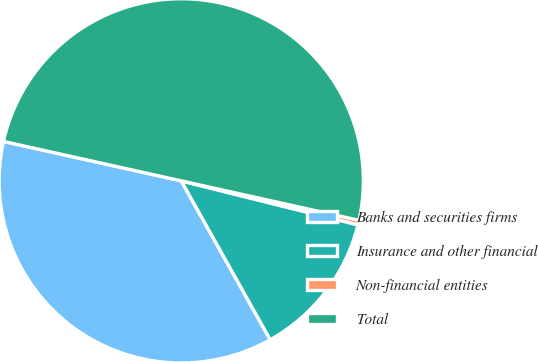Convert chart. <chart><loc_0><loc_0><loc_500><loc_500><pie_chart><fcel>Banks and securities firms<fcel>Insurance and other financial<fcel>Non-financial entities<fcel>Total<nl><fcel>36.6%<fcel>12.99%<fcel>0.41%<fcel>50.0%<nl></chart> 